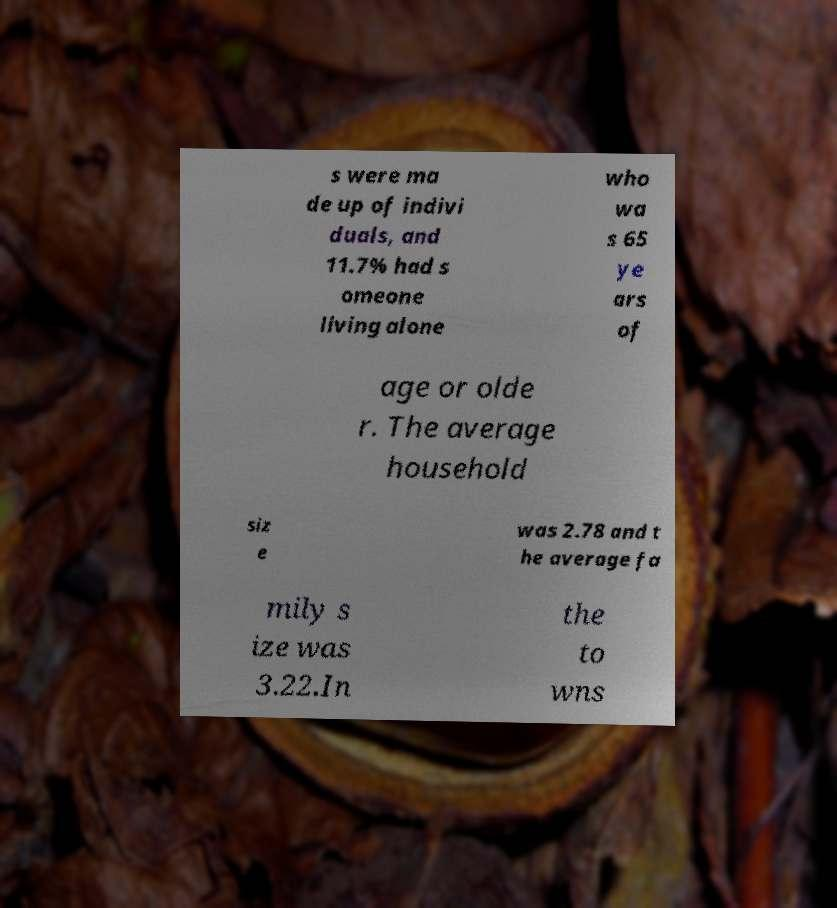Can you read and provide the text displayed in the image?This photo seems to have some interesting text. Can you extract and type it out for me? s were ma de up of indivi duals, and 11.7% had s omeone living alone who wa s 65 ye ars of age or olde r. The average household siz e was 2.78 and t he average fa mily s ize was 3.22.In the to wns 